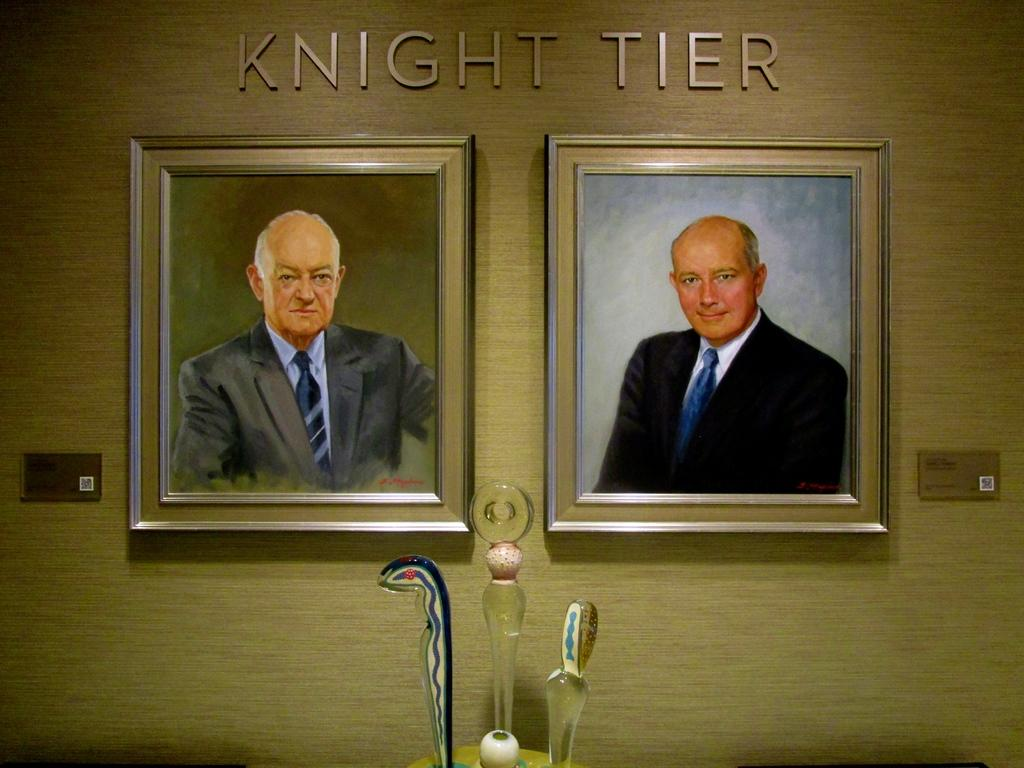<image>
Summarize the visual content of the image. Two pictures of men under the words "Knight Tier". 